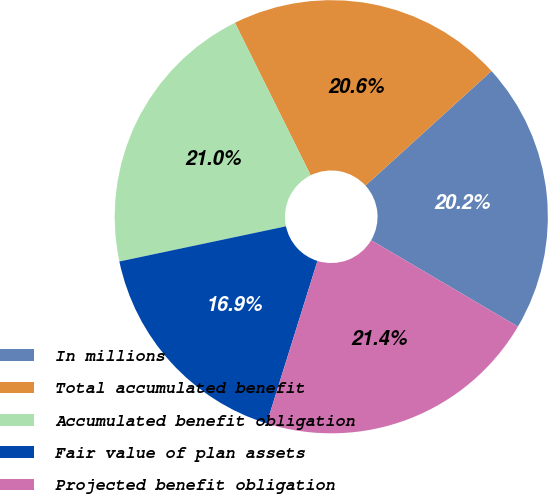Convert chart to OTSL. <chart><loc_0><loc_0><loc_500><loc_500><pie_chart><fcel>In millions<fcel>Total accumulated benefit<fcel>Accumulated benefit obligation<fcel>Fair value of plan assets<fcel>Projected benefit obligation<nl><fcel>20.21%<fcel>20.59%<fcel>20.97%<fcel>16.87%<fcel>21.35%<nl></chart> 